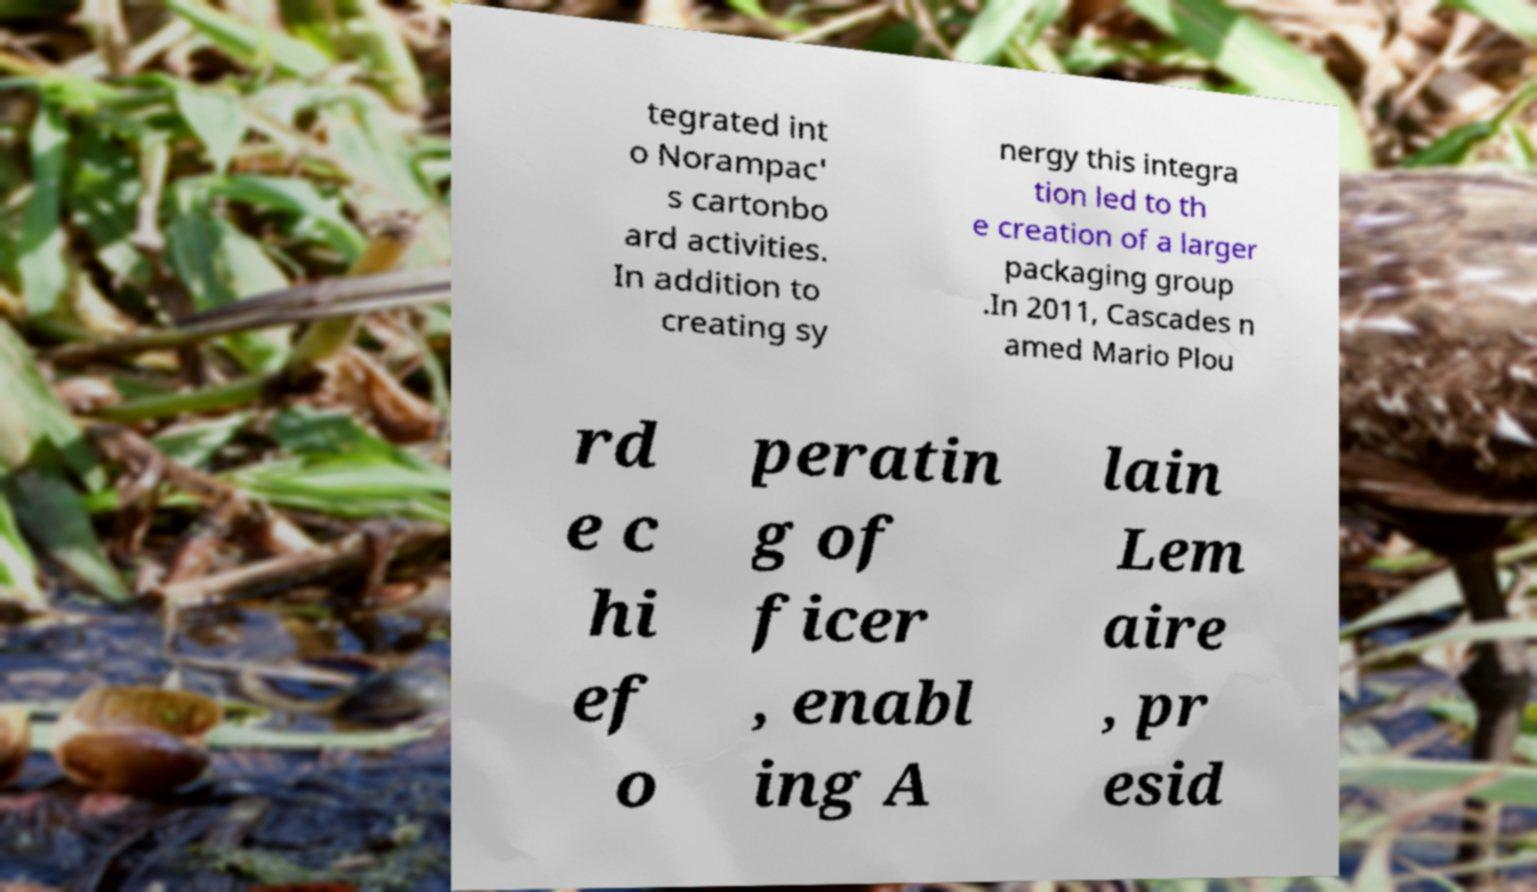Please identify and transcribe the text found in this image. tegrated int o Norampac' s cartonbo ard activities. In addition to creating sy nergy this integra tion led to th e creation of a larger packaging group .In 2011, Cascades n amed Mario Plou rd e c hi ef o peratin g of ficer , enabl ing A lain Lem aire , pr esid 